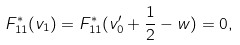<formula> <loc_0><loc_0><loc_500><loc_500>F ^ { * } _ { 1 1 } ( v _ { 1 } ) = F ^ { * } _ { 1 1 } ( v ^ { \prime } _ { 0 } + \frac { 1 } { 2 } - w ) = 0 ,</formula> 